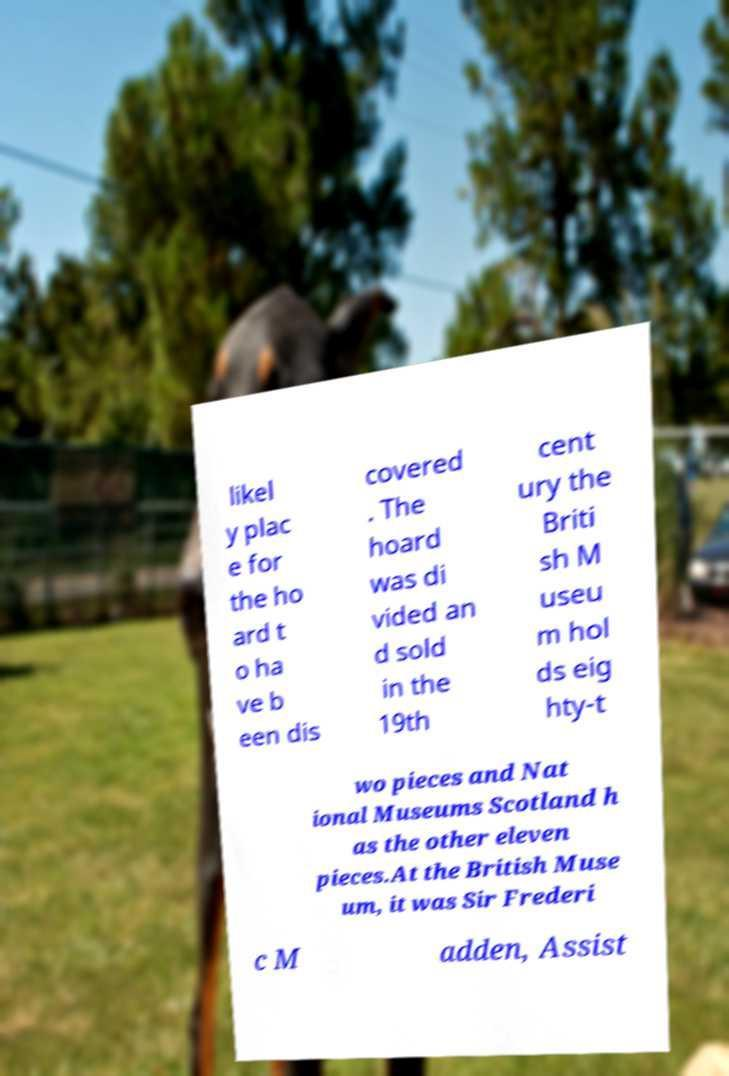For documentation purposes, I need the text within this image transcribed. Could you provide that? likel y plac e for the ho ard t o ha ve b een dis covered . The hoard was di vided an d sold in the 19th cent ury the Briti sh M useu m hol ds eig hty-t wo pieces and Nat ional Museums Scotland h as the other eleven pieces.At the British Muse um, it was Sir Frederi c M adden, Assist 